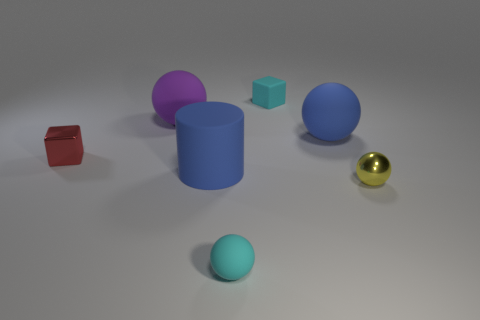What color is the matte ball that is the same size as the purple thing? blue 